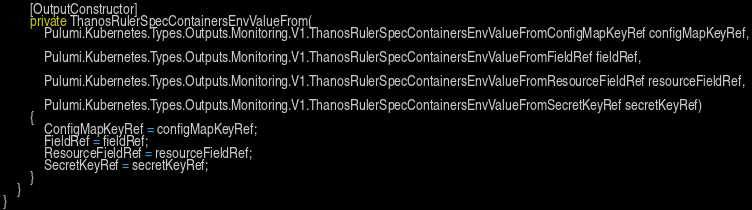Convert code to text. <code><loc_0><loc_0><loc_500><loc_500><_C#_>        [OutputConstructor]
        private ThanosRulerSpecContainersEnvValueFrom(
            Pulumi.Kubernetes.Types.Outputs.Monitoring.V1.ThanosRulerSpecContainersEnvValueFromConfigMapKeyRef configMapKeyRef,

            Pulumi.Kubernetes.Types.Outputs.Monitoring.V1.ThanosRulerSpecContainersEnvValueFromFieldRef fieldRef,

            Pulumi.Kubernetes.Types.Outputs.Monitoring.V1.ThanosRulerSpecContainersEnvValueFromResourceFieldRef resourceFieldRef,

            Pulumi.Kubernetes.Types.Outputs.Monitoring.V1.ThanosRulerSpecContainersEnvValueFromSecretKeyRef secretKeyRef)
        {
            ConfigMapKeyRef = configMapKeyRef;
            FieldRef = fieldRef;
            ResourceFieldRef = resourceFieldRef;
            SecretKeyRef = secretKeyRef;
        }
    }
}
</code> 